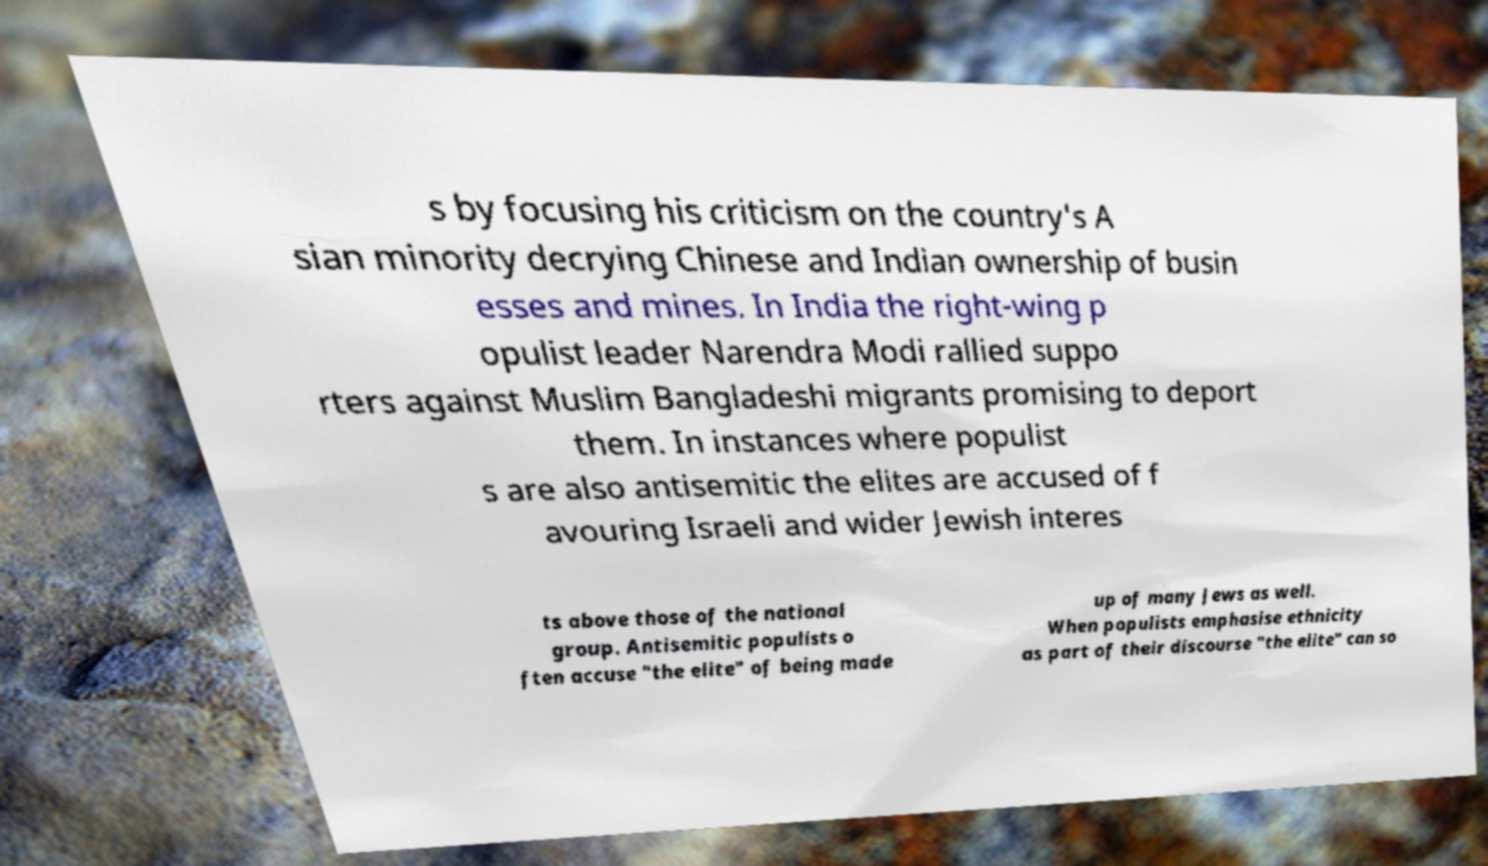For documentation purposes, I need the text within this image transcribed. Could you provide that? s by focusing his criticism on the country's A sian minority decrying Chinese and Indian ownership of busin esses and mines. In India the right-wing p opulist leader Narendra Modi rallied suppo rters against Muslim Bangladeshi migrants promising to deport them. In instances where populist s are also antisemitic the elites are accused of f avouring Israeli and wider Jewish interes ts above those of the national group. Antisemitic populists o ften accuse "the elite" of being made up of many Jews as well. When populists emphasise ethnicity as part of their discourse "the elite" can so 